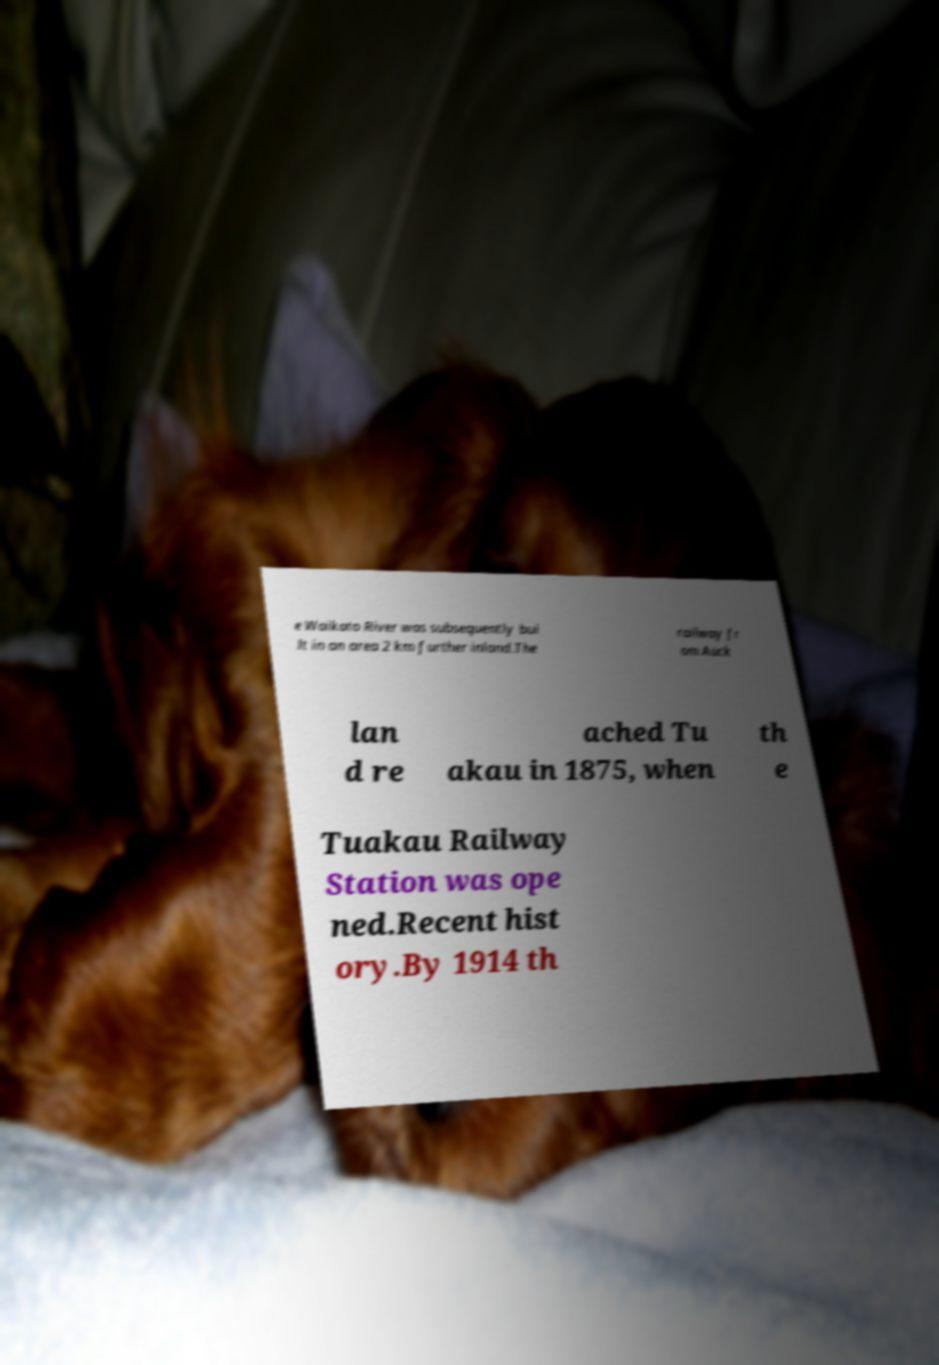Could you extract and type out the text from this image? e Waikato River was subsequently bui lt in an area 2 km further inland.The railway fr om Auck lan d re ached Tu akau in 1875, when th e Tuakau Railway Station was ope ned.Recent hist ory.By 1914 th 